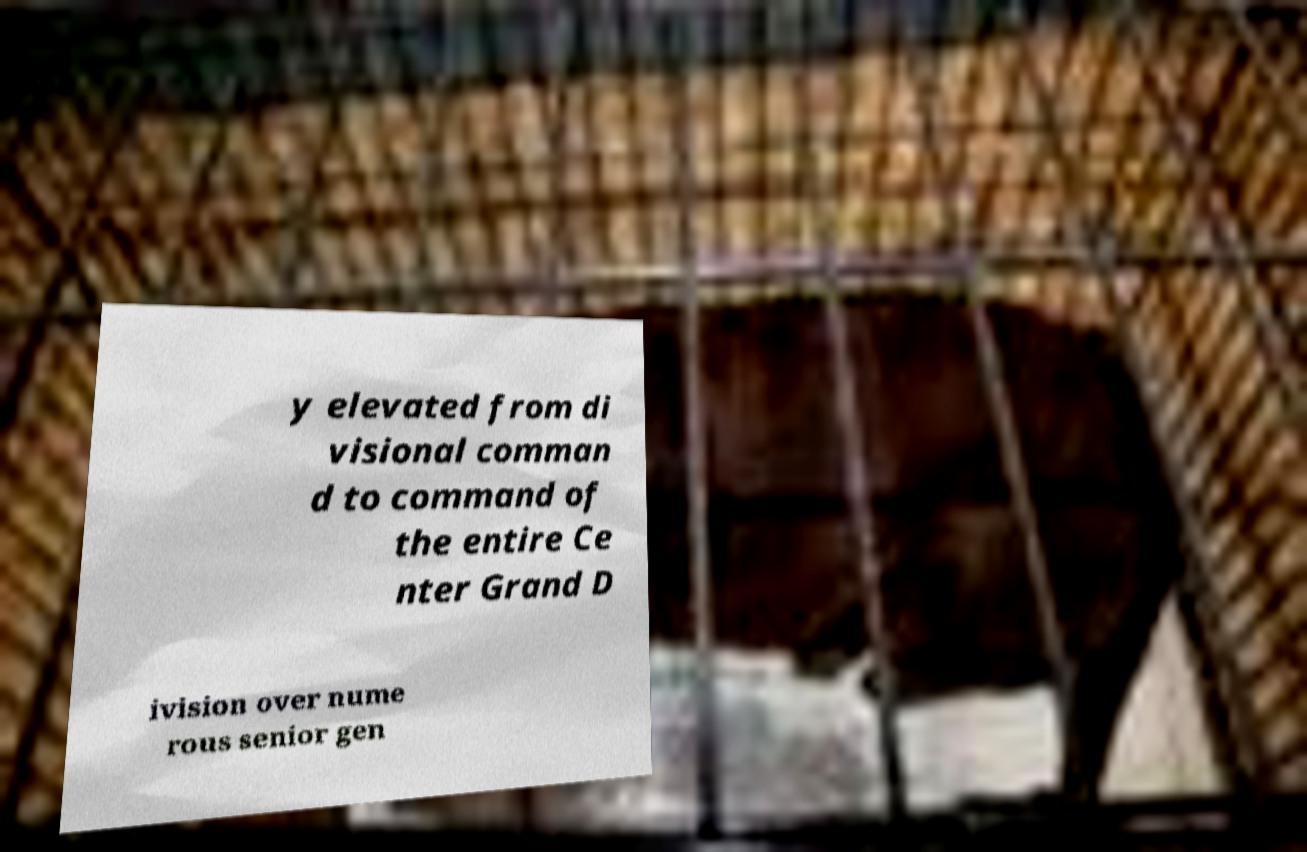Can you accurately transcribe the text from the provided image for me? y elevated from di visional comman d to command of the entire Ce nter Grand D ivision over nume rous senior gen 